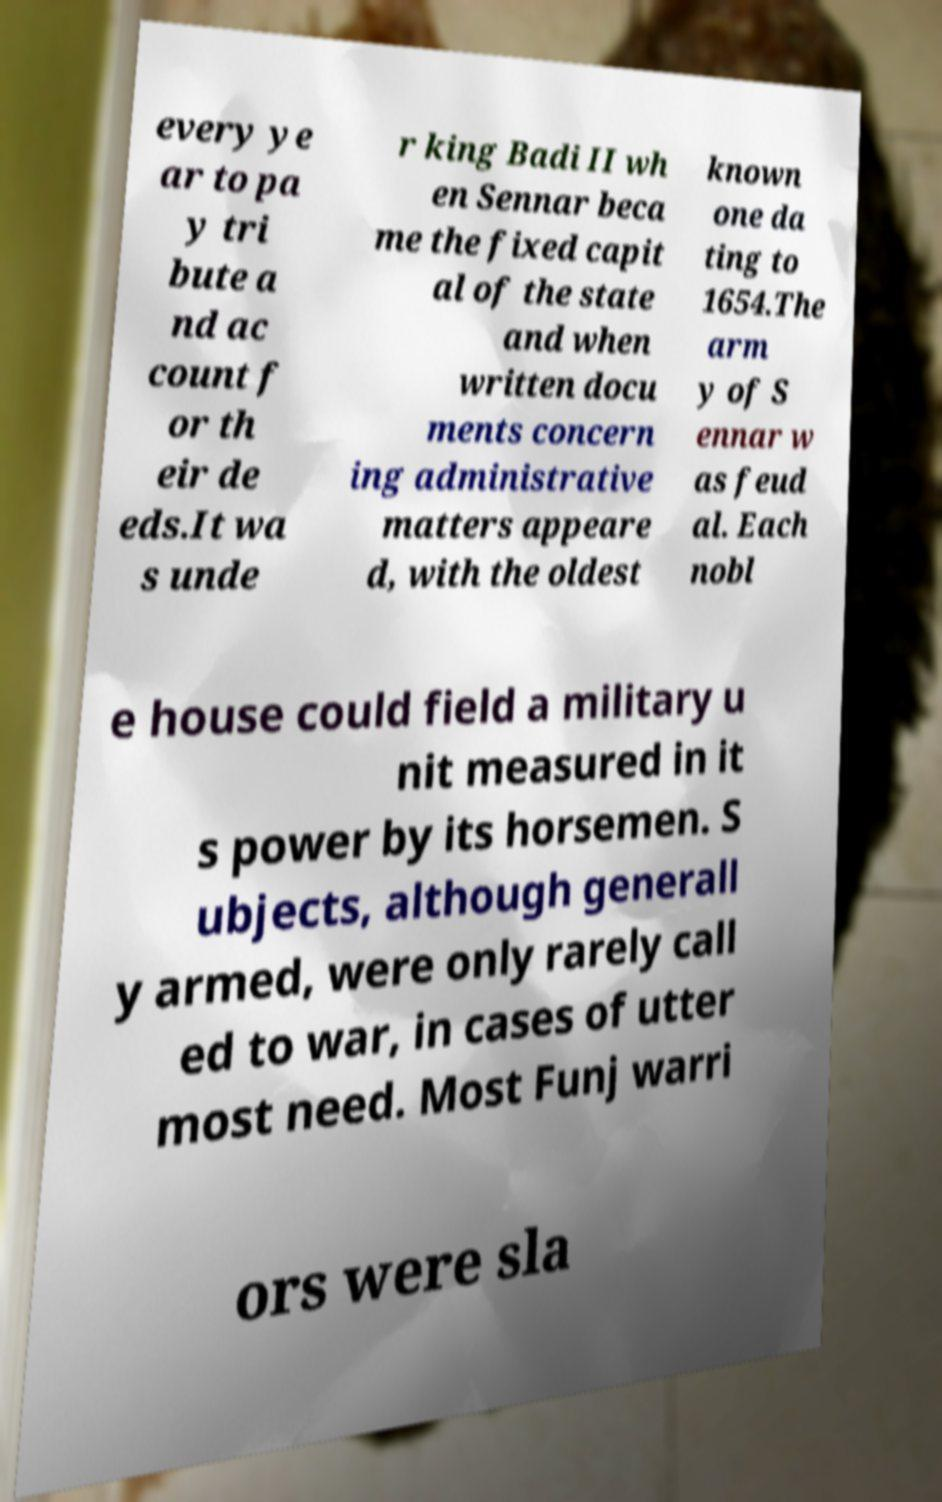Could you assist in decoding the text presented in this image and type it out clearly? every ye ar to pa y tri bute a nd ac count f or th eir de eds.It wa s unde r king Badi II wh en Sennar beca me the fixed capit al of the state and when written docu ments concern ing administrative matters appeare d, with the oldest known one da ting to 1654.The arm y of S ennar w as feud al. Each nobl e house could field a military u nit measured in it s power by its horsemen. S ubjects, although generall y armed, were only rarely call ed to war, in cases of utter most need. Most Funj warri ors were sla 